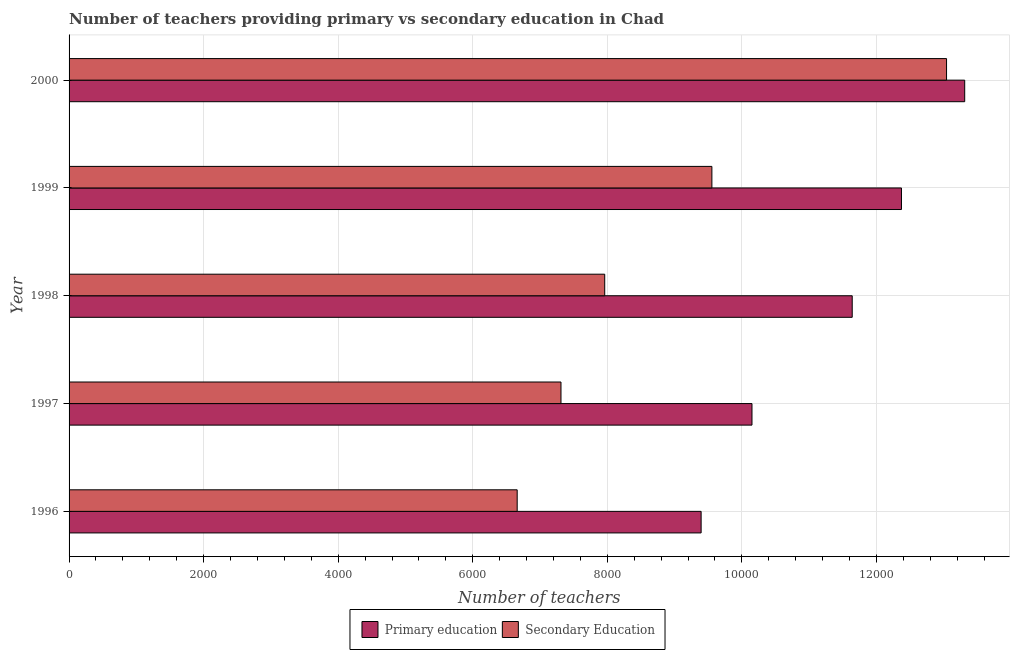How many different coloured bars are there?
Ensure brevity in your answer.  2. Are the number of bars per tick equal to the number of legend labels?
Keep it short and to the point. Yes. Are the number of bars on each tick of the Y-axis equal?
Provide a short and direct response. Yes. How many bars are there on the 5th tick from the bottom?
Offer a terse response. 2. In how many cases, is the number of bars for a given year not equal to the number of legend labels?
Offer a very short reply. 0. What is the number of primary teachers in 1996?
Give a very brief answer. 9395. Across all years, what is the maximum number of secondary teachers?
Your answer should be very brief. 1.30e+04. Across all years, what is the minimum number of primary teachers?
Provide a succinct answer. 9395. In which year was the number of primary teachers maximum?
Your response must be concise. 2000. What is the total number of secondary teachers in the graph?
Provide a succinct answer. 4.45e+04. What is the difference between the number of primary teachers in 1996 and that in 1997?
Keep it short and to the point. -756. What is the difference between the number of primary teachers in 1997 and the number of secondary teachers in 1999?
Provide a succinct answer. 596. What is the average number of secondary teachers per year?
Ensure brevity in your answer.  8906.6. In the year 1997, what is the difference between the number of primary teachers and number of secondary teachers?
Your answer should be very brief. 2839. What is the ratio of the number of primary teachers in 1998 to that in 1999?
Your answer should be very brief. 0.94. What is the difference between the highest and the second highest number of primary teachers?
Make the answer very short. 940. What is the difference between the highest and the lowest number of secondary teachers?
Your response must be concise. 6382. Is the sum of the number of primary teachers in 1997 and 2000 greater than the maximum number of secondary teachers across all years?
Make the answer very short. Yes. What does the 1st bar from the top in 2000 represents?
Provide a succinct answer. Secondary Education. What does the 1st bar from the bottom in 1996 represents?
Give a very brief answer. Primary education. How many bars are there?
Ensure brevity in your answer.  10. How many years are there in the graph?
Your answer should be very brief. 5. What is the difference between two consecutive major ticks on the X-axis?
Provide a short and direct response. 2000. What is the title of the graph?
Your answer should be very brief. Number of teachers providing primary vs secondary education in Chad. Does "Formally registered" appear as one of the legend labels in the graph?
Offer a terse response. No. What is the label or title of the X-axis?
Your answer should be very brief. Number of teachers. What is the label or title of the Y-axis?
Your answer should be very brief. Year. What is the Number of teachers in Primary education in 1996?
Offer a very short reply. 9395. What is the Number of teachers of Secondary Education in 1996?
Give a very brief answer. 6661. What is the Number of teachers of Primary education in 1997?
Make the answer very short. 1.02e+04. What is the Number of teachers in Secondary Education in 1997?
Give a very brief answer. 7312. What is the Number of teachers in Primary education in 1998?
Your response must be concise. 1.16e+04. What is the Number of teachers in Secondary Education in 1998?
Provide a short and direct response. 7962. What is the Number of teachers in Primary education in 1999?
Offer a very short reply. 1.24e+04. What is the Number of teachers in Secondary Education in 1999?
Make the answer very short. 9555. What is the Number of teachers of Primary education in 2000?
Make the answer very short. 1.33e+04. What is the Number of teachers in Secondary Education in 2000?
Offer a terse response. 1.30e+04. Across all years, what is the maximum Number of teachers in Primary education?
Your response must be concise. 1.33e+04. Across all years, what is the maximum Number of teachers in Secondary Education?
Ensure brevity in your answer.  1.30e+04. Across all years, what is the minimum Number of teachers of Primary education?
Give a very brief answer. 9395. Across all years, what is the minimum Number of teachers in Secondary Education?
Your answer should be very brief. 6661. What is the total Number of teachers of Primary education in the graph?
Your answer should be compact. 5.69e+04. What is the total Number of teachers in Secondary Education in the graph?
Offer a terse response. 4.45e+04. What is the difference between the Number of teachers of Primary education in 1996 and that in 1997?
Keep it short and to the point. -756. What is the difference between the Number of teachers in Secondary Education in 1996 and that in 1997?
Make the answer very short. -651. What is the difference between the Number of teachers in Primary education in 1996 and that in 1998?
Keep it short and to the point. -2246. What is the difference between the Number of teachers in Secondary Education in 1996 and that in 1998?
Provide a succinct answer. -1301. What is the difference between the Number of teachers in Primary education in 1996 and that in 1999?
Offer a terse response. -2978. What is the difference between the Number of teachers in Secondary Education in 1996 and that in 1999?
Provide a succinct answer. -2894. What is the difference between the Number of teachers in Primary education in 1996 and that in 2000?
Make the answer very short. -3918. What is the difference between the Number of teachers of Secondary Education in 1996 and that in 2000?
Offer a very short reply. -6382. What is the difference between the Number of teachers in Primary education in 1997 and that in 1998?
Your response must be concise. -1490. What is the difference between the Number of teachers of Secondary Education in 1997 and that in 1998?
Offer a terse response. -650. What is the difference between the Number of teachers in Primary education in 1997 and that in 1999?
Give a very brief answer. -2222. What is the difference between the Number of teachers in Secondary Education in 1997 and that in 1999?
Your answer should be very brief. -2243. What is the difference between the Number of teachers of Primary education in 1997 and that in 2000?
Offer a terse response. -3162. What is the difference between the Number of teachers in Secondary Education in 1997 and that in 2000?
Offer a very short reply. -5731. What is the difference between the Number of teachers in Primary education in 1998 and that in 1999?
Make the answer very short. -732. What is the difference between the Number of teachers of Secondary Education in 1998 and that in 1999?
Keep it short and to the point. -1593. What is the difference between the Number of teachers in Primary education in 1998 and that in 2000?
Provide a succinct answer. -1672. What is the difference between the Number of teachers in Secondary Education in 1998 and that in 2000?
Your answer should be compact. -5081. What is the difference between the Number of teachers in Primary education in 1999 and that in 2000?
Keep it short and to the point. -940. What is the difference between the Number of teachers of Secondary Education in 1999 and that in 2000?
Offer a terse response. -3488. What is the difference between the Number of teachers of Primary education in 1996 and the Number of teachers of Secondary Education in 1997?
Provide a short and direct response. 2083. What is the difference between the Number of teachers of Primary education in 1996 and the Number of teachers of Secondary Education in 1998?
Provide a short and direct response. 1433. What is the difference between the Number of teachers of Primary education in 1996 and the Number of teachers of Secondary Education in 1999?
Give a very brief answer. -160. What is the difference between the Number of teachers in Primary education in 1996 and the Number of teachers in Secondary Education in 2000?
Offer a terse response. -3648. What is the difference between the Number of teachers in Primary education in 1997 and the Number of teachers in Secondary Education in 1998?
Offer a terse response. 2189. What is the difference between the Number of teachers in Primary education in 1997 and the Number of teachers in Secondary Education in 1999?
Give a very brief answer. 596. What is the difference between the Number of teachers in Primary education in 1997 and the Number of teachers in Secondary Education in 2000?
Keep it short and to the point. -2892. What is the difference between the Number of teachers in Primary education in 1998 and the Number of teachers in Secondary Education in 1999?
Keep it short and to the point. 2086. What is the difference between the Number of teachers in Primary education in 1998 and the Number of teachers in Secondary Education in 2000?
Offer a terse response. -1402. What is the difference between the Number of teachers of Primary education in 1999 and the Number of teachers of Secondary Education in 2000?
Your answer should be very brief. -670. What is the average Number of teachers of Primary education per year?
Offer a terse response. 1.14e+04. What is the average Number of teachers of Secondary Education per year?
Ensure brevity in your answer.  8906.6. In the year 1996, what is the difference between the Number of teachers in Primary education and Number of teachers in Secondary Education?
Make the answer very short. 2734. In the year 1997, what is the difference between the Number of teachers in Primary education and Number of teachers in Secondary Education?
Make the answer very short. 2839. In the year 1998, what is the difference between the Number of teachers in Primary education and Number of teachers in Secondary Education?
Your answer should be compact. 3679. In the year 1999, what is the difference between the Number of teachers in Primary education and Number of teachers in Secondary Education?
Give a very brief answer. 2818. In the year 2000, what is the difference between the Number of teachers in Primary education and Number of teachers in Secondary Education?
Make the answer very short. 270. What is the ratio of the Number of teachers of Primary education in 1996 to that in 1997?
Keep it short and to the point. 0.93. What is the ratio of the Number of teachers in Secondary Education in 1996 to that in 1997?
Provide a succinct answer. 0.91. What is the ratio of the Number of teachers of Primary education in 1996 to that in 1998?
Make the answer very short. 0.81. What is the ratio of the Number of teachers in Secondary Education in 1996 to that in 1998?
Ensure brevity in your answer.  0.84. What is the ratio of the Number of teachers in Primary education in 1996 to that in 1999?
Your response must be concise. 0.76. What is the ratio of the Number of teachers in Secondary Education in 1996 to that in 1999?
Your response must be concise. 0.7. What is the ratio of the Number of teachers of Primary education in 1996 to that in 2000?
Offer a terse response. 0.71. What is the ratio of the Number of teachers of Secondary Education in 1996 to that in 2000?
Your answer should be compact. 0.51. What is the ratio of the Number of teachers in Primary education in 1997 to that in 1998?
Your answer should be very brief. 0.87. What is the ratio of the Number of teachers of Secondary Education in 1997 to that in 1998?
Keep it short and to the point. 0.92. What is the ratio of the Number of teachers in Primary education in 1997 to that in 1999?
Ensure brevity in your answer.  0.82. What is the ratio of the Number of teachers of Secondary Education in 1997 to that in 1999?
Your answer should be very brief. 0.77. What is the ratio of the Number of teachers of Primary education in 1997 to that in 2000?
Provide a short and direct response. 0.76. What is the ratio of the Number of teachers in Secondary Education in 1997 to that in 2000?
Make the answer very short. 0.56. What is the ratio of the Number of teachers in Primary education in 1998 to that in 1999?
Offer a terse response. 0.94. What is the ratio of the Number of teachers of Primary education in 1998 to that in 2000?
Provide a succinct answer. 0.87. What is the ratio of the Number of teachers in Secondary Education in 1998 to that in 2000?
Offer a terse response. 0.61. What is the ratio of the Number of teachers in Primary education in 1999 to that in 2000?
Keep it short and to the point. 0.93. What is the ratio of the Number of teachers of Secondary Education in 1999 to that in 2000?
Ensure brevity in your answer.  0.73. What is the difference between the highest and the second highest Number of teachers of Primary education?
Make the answer very short. 940. What is the difference between the highest and the second highest Number of teachers in Secondary Education?
Provide a succinct answer. 3488. What is the difference between the highest and the lowest Number of teachers of Primary education?
Provide a short and direct response. 3918. What is the difference between the highest and the lowest Number of teachers of Secondary Education?
Ensure brevity in your answer.  6382. 